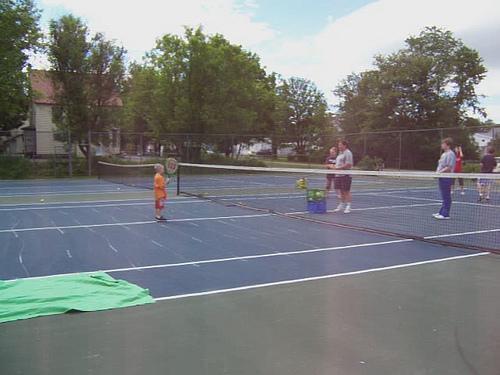How many people are on the left of the net?
Give a very brief answer. 1. 